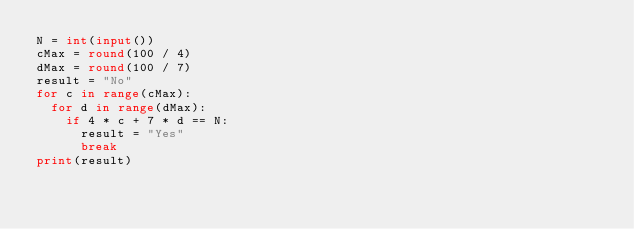Convert code to text. <code><loc_0><loc_0><loc_500><loc_500><_Python_>N = int(input())
cMax = round(100 / 4)
dMax = round(100 / 7)
result = "No"
for c in range(cMax):
  for d in range(dMax):
    if 4 * c + 7 * d == N:
      result = "Yes"
      break
print(result)</code> 